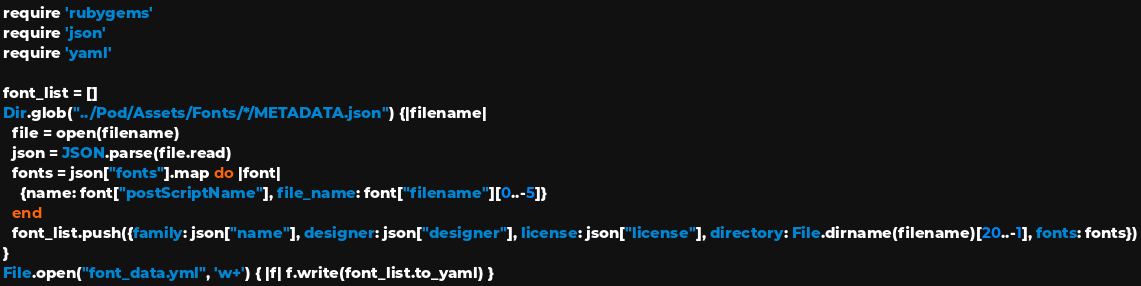Convert code to text. <code><loc_0><loc_0><loc_500><loc_500><_Ruby_>require 'rubygems'
require 'json'
require 'yaml'

font_list = []
Dir.glob("../Pod/Assets/Fonts/*/METADATA.json") {|filename|
  file = open(filename)
  json = JSON.parse(file.read)
  fonts = json["fonts"].map do |font|
    {name: font["postScriptName"], file_name: font["filename"][0..-5]}
  end
  font_list.push({family: json["name"], designer: json["designer"], license: json["license"], directory: File.dirname(filename)[20..-1], fonts: fonts})
}
File.open("font_data.yml", 'w+') { |f| f.write(font_list.to_yaml) }
</code> 